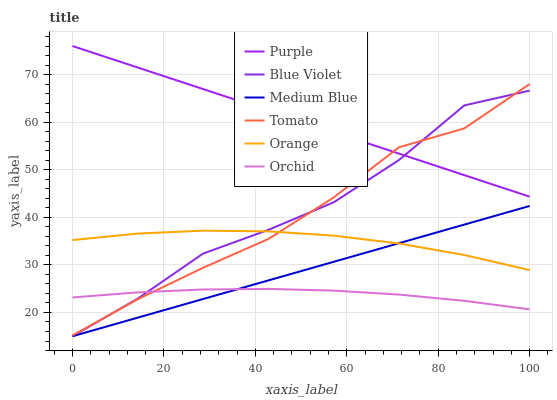Does Orchid have the minimum area under the curve?
Answer yes or no. Yes. Does Purple have the maximum area under the curve?
Answer yes or no. Yes. Does Medium Blue have the minimum area under the curve?
Answer yes or no. No. Does Medium Blue have the maximum area under the curve?
Answer yes or no. No. Is Medium Blue the smoothest?
Answer yes or no. Yes. Is Blue Violet the roughest?
Answer yes or no. Yes. Is Purple the smoothest?
Answer yes or no. No. Is Purple the roughest?
Answer yes or no. No. Does Medium Blue have the lowest value?
Answer yes or no. Yes. Does Purple have the lowest value?
Answer yes or no. No. Does Purple have the highest value?
Answer yes or no. Yes. Does Medium Blue have the highest value?
Answer yes or no. No. Is Orchid less than Orange?
Answer yes or no. Yes. Is Purple greater than Orchid?
Answer yes or no. Yes. Does Orange intersect Medium Blue?
Answer yes or no. Yes. Is Orange less than Medium Blue?
Answer yes or no. No. Is Orange greater than Medium Blue?
Answer yes or no. No. Does Orchid intersect Orange?
Answer yes or no. No. 